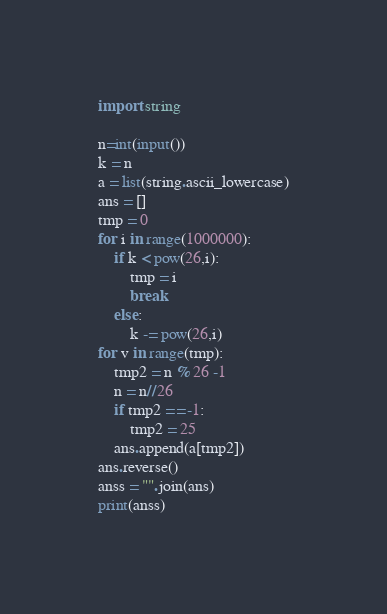Convert code to text. <code><loc_0><loc_0><loc_500><loc_500><_Python_>import string

n=int(input())
k = n
a = list(string.ascii_lowercase)
ans = []
tmp = 0
for i in range(1000000):
    if k < pow(26,i):
        tmp = i
        break
    else:
        k -= pow(26,i)
for v in range(tmp):
    tmp2 = n % 26 -1
    n = n//26
    if tmp2 == -1:
        tmp2 = 25
    ans.append(a[tmp2])
ans.reverse()
anss = "".join(ans)
print(anss)</code> 